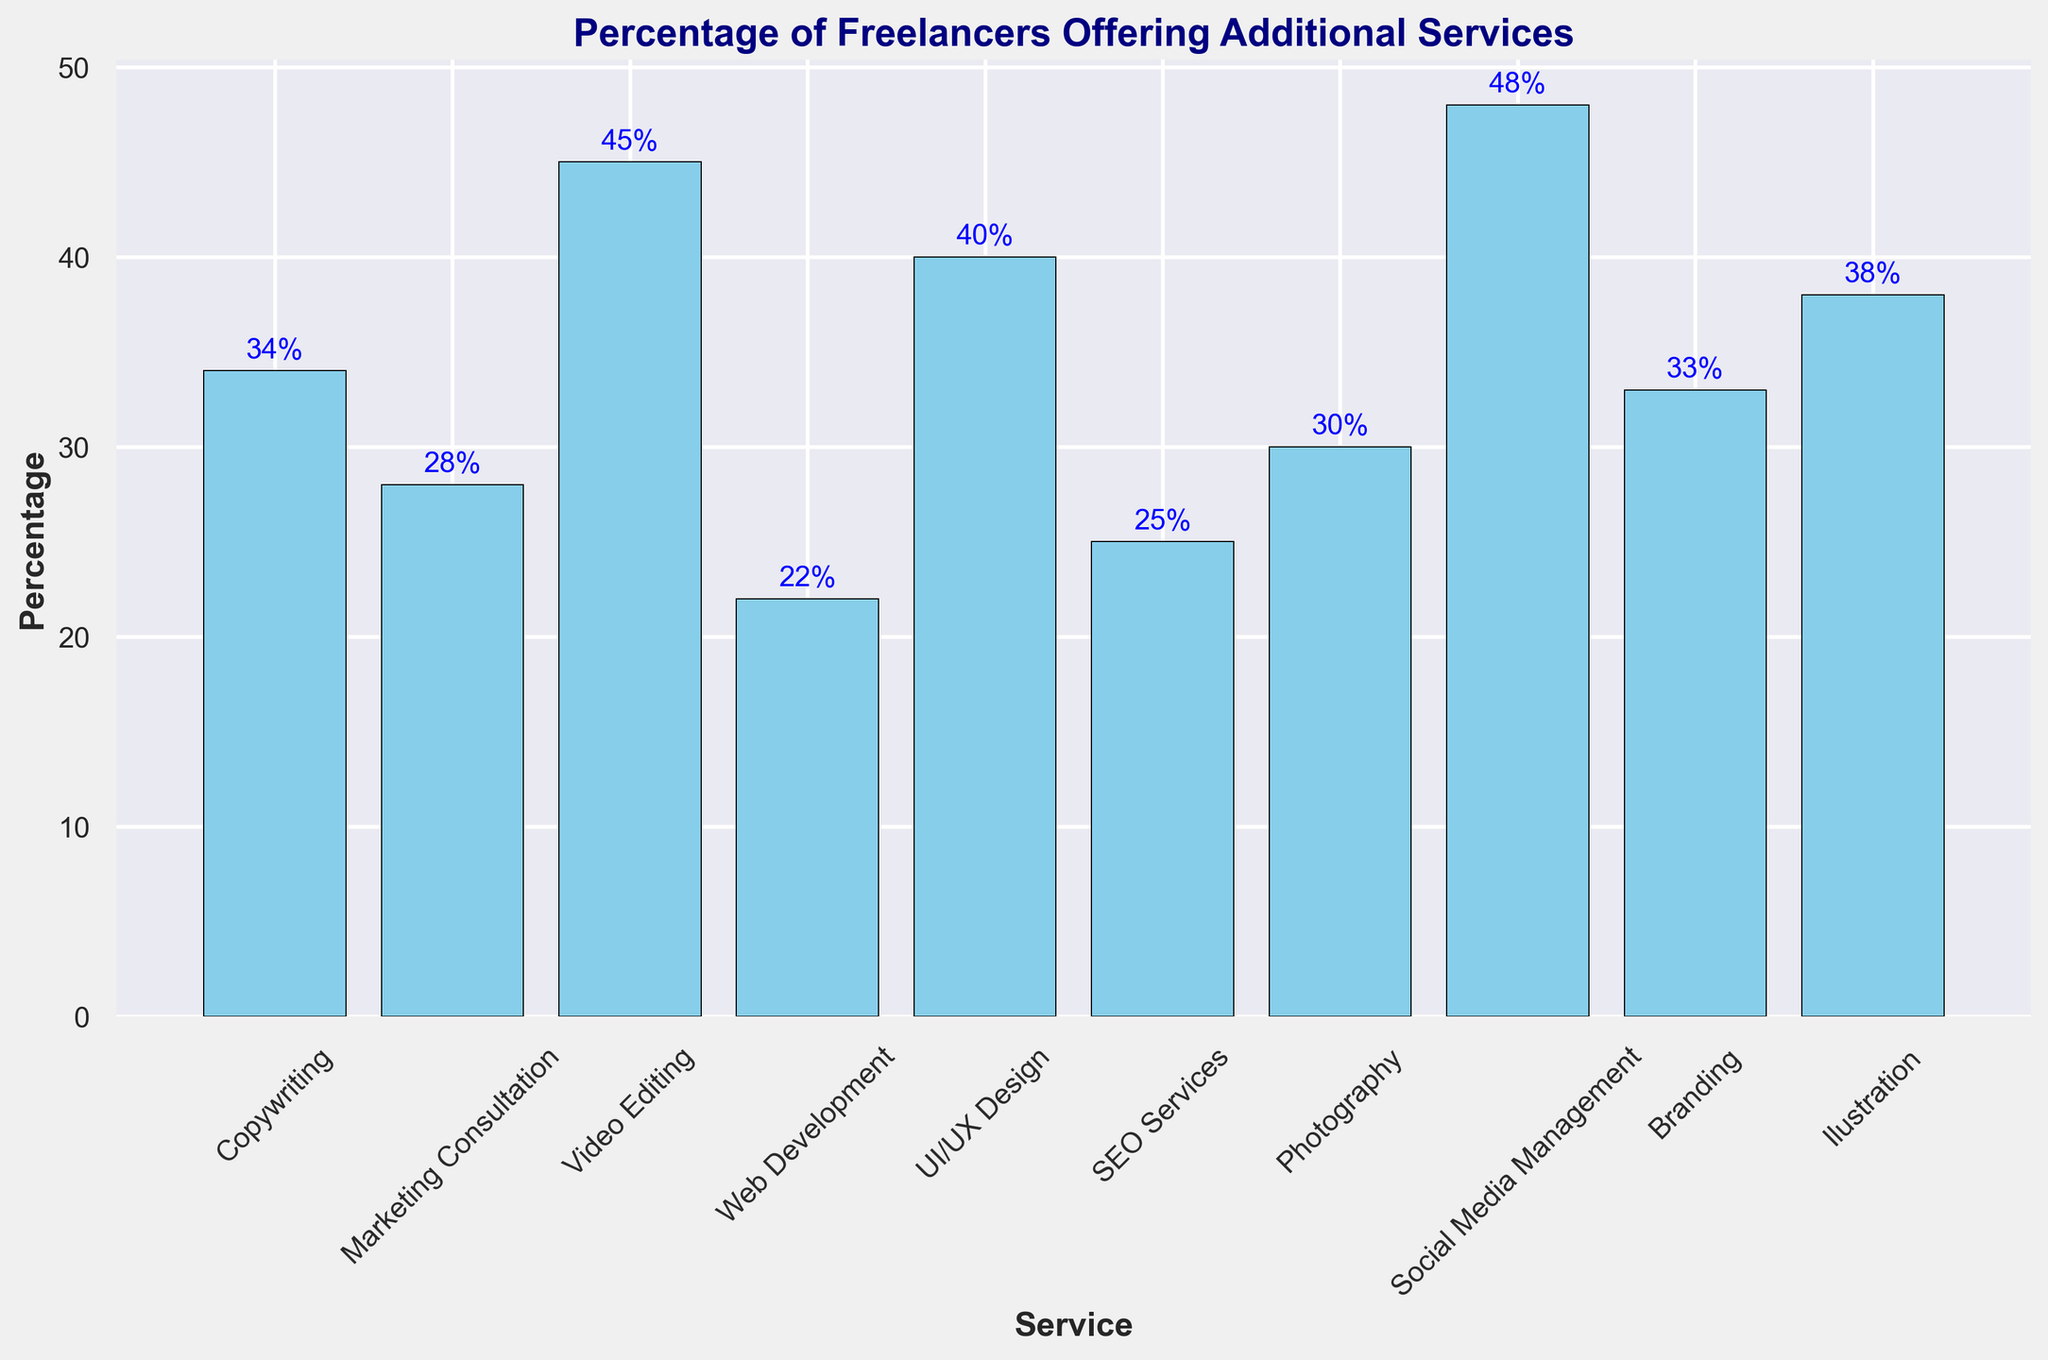Which service has the highest percentage of freelancers offering it? The service with the highest bar represents the highest percentage. The highest bar corresponds to Social Media Management at 48%.
Answer: Social Media Management Which service has the lowest percentage of freelancers offering it? The service with the lowest bar indicates the lowest percentage. The lowest bar corresponds to Web Development at 22%.
Answer: Web Development What is the difference in percentage between the service with the highest offering and the service with the lowest offering? The highest percentage is for Social Media Management (48%) and the lowest is for Web Development (22%). The difference is 48% - 22% = 26%.
Answer: 26% How many services have at least 40% of freelancers offering them? Look at the bars to see which ones are at least 40%. Services that are at least 40% are Video Editing (45%), UI/UX Design (40%), Social Media Management (48%), and Illustration (38%). There are 4 services.
Answer: 4 Which services have a higher percentage of freelancers offering them than Copywriting? Copywriting has 34%. Services with higher percentages are Video Editing (45%), UI/UX Design (40%), Social Media Management (48%), and Illustration (38%).
Answer: Video Editing, UI/UX Design, Social Media Management, Illustration What is the combined percentage of freelancers offering Marketing Consultation and SEO Services? Marketing Consultation is 28% and SEO Services is 25%. Their combined percentage is 28% + 25% = 53%.
Answer: 53% Which service has a bar color distinct from others? The bars are all the same color, skyblue. Therefore, none of the services have a distinct bar color.
Answer: None What is the average percentage of freelancers offering Web Development, SEO Services, and Branding? Add the percentages: Web Development (22%), SEO Services (25%), and Branding (33%). The total is 22% + 25% + 33% = 80%. The average is 80% / 3 = 26.67%.
Answer: 26.67% Which service's bar is annotated with 38%? The bar with 38% annotation corresponds to Illustration.
Answer: Illustration Compare the percentage of freelancers offering Copywriting and Photography. Which has more and by what percentage? Copywriting is at 34% and Photography is at 30%. The difference is 34% - 30% = 4%. Copywriting has more by 4%.
Answer: Copywriting, 4% 